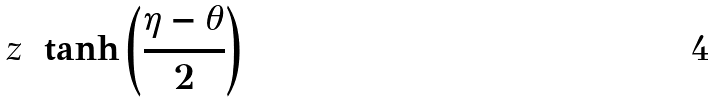<formula> <loc_0><loc_0><loc_500><loc_500>z = \tanh \left ( \frac { \eta - \theta } { 2 } \right )</formula> 